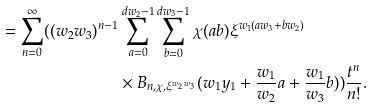<formula> <loc_0><loc_0><loc_500><loc_500>= \sum _ { n = 0 } ^ { \infty } ( ( w _ { 2 } w _ { 3 } ) ^ { n - 1 } & \sum _ { a = 0 } ^ { d w _ { 2 } - 1 } \sum _ { b = 0 } ^ { d w _ { 3 } - 1 } \chi ( a b ) \xi ^ { w _ { 1 } ( a w _ { 3 } + b w _ { 2 } ) } \\ & \times B _ { n , \chi , \xi ^ { w _ { 2 } w _ { 3 } } } ( w _ { 1 } y _ { 1 } + \frac { w _ { 1 } } { w _ { 2 } } a + \frac { w _ { 1 } } { w _ { 3 } } b ) ) \frac { t ^ { n } } { n ! } .</formula> 